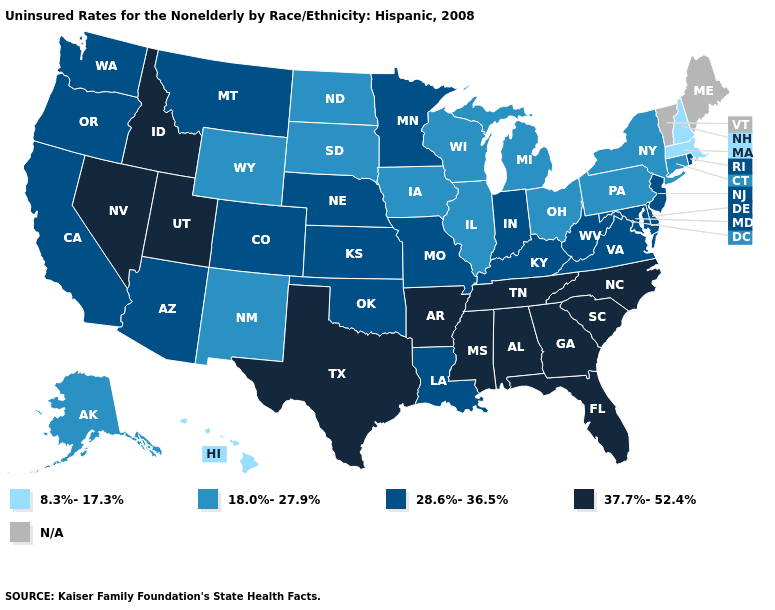Does the first symbol in the legend represent the smallest category?
Give a very brief answer. Yes. Name the states that have a value in the range 37.7%-52.4%?
Be succinct. Alabama, Arkansas, Florida, Georgia, Idaho, Mississippi, Nevada, North Carolina, South Carolina, Tennessee, Texas, Utah. Among the states that border Nevada , which have the highest value?
Keep it brief. Idaho, Utah. What is the highest value in the USA?
Give a very brief answer. 37.7%-52.4%. Name the states that have a value in the range 18.0%-27.9%?
Concise answer only. Alaska, Connecticut, Illinois, Iowa, Michigan, New Mexico, New York, North Dakota, Ohio, Pennsylvania, South Dakota, Wisconsin, Wyoming. What is the value of Delaware?
Answer briefly. 28.6%-36.5%. Name the states that have a value in the range 18.0%-27.9%?
Give a very brief answer. Alaska, Connecticut, Illinois, Iowa, Michigan, New Mexico, New York, North Dakota, Ohio, Pennsylvania, South Dakota, Wisconsin, Wyoming. Does the map have missing data?
Concise answer only. Yes. What is the highest value in the USA?
Be succinct. 37.7%-52.4%. Name the states that have a value in the range 8.3%-17.3%?
Short answer required. Hawaii, Massachusetts, New Hampshire. Does Hawaii have the lowest value in the West?
Answer briefly. Yes. Does the map have missing data?
Keep it brief. Yes. What is the lowest value in the MidWest?
Keep it brief. 18.0%-27.9%. Among the states that border North Dakota , which have the lowest value?
Write a very short answer. South Dakota. 